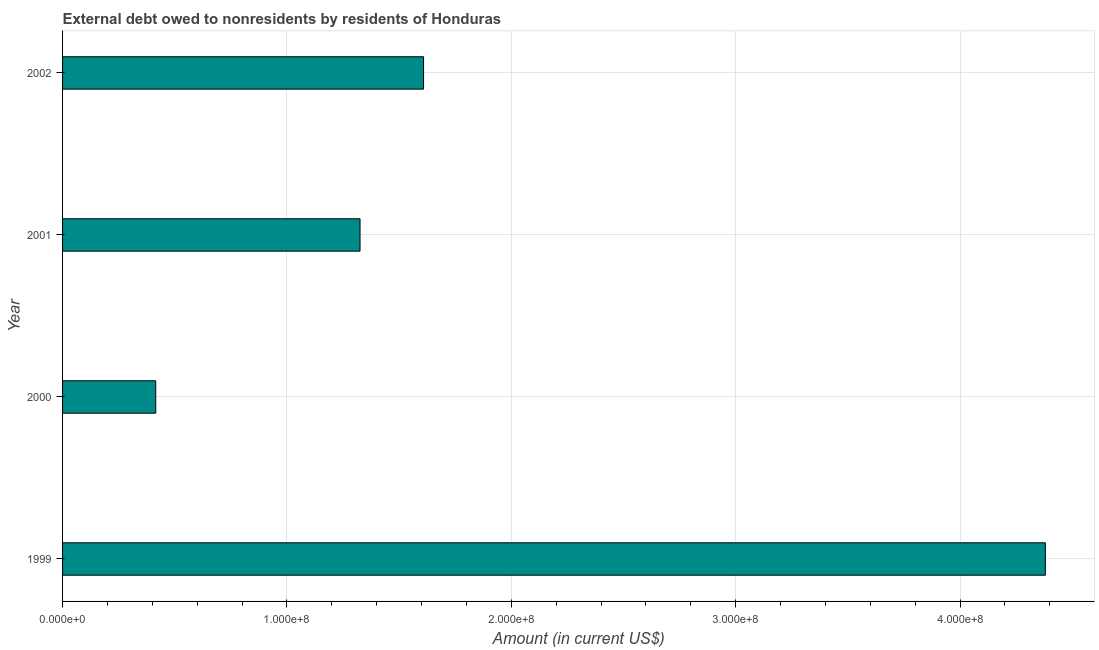Does the graph contain any zero values?
Your response must be concise. No. Does the graph contain grids?
Provide a short and direct response. Yes. What is the title of the graph?
Ensure brevity in your answer.  External debt owed to nonresidents by residents of Honduras. What is the label or title of the X-axis?
Make the answer very short. Amount (in current US$). What is the debt in 2001?
Ensure brevity in your answer.  1.33e+08. Across all years, what is the maximum debt?
Provide a succinct answer. 4.38e+08. Across all years, what is the minimum debt?
Your response must be concise. 4.15e+07. What is the sum of the debt?
Ensure brevity in your answer.  7.73e+08. What is the difference between the debt in 2001 and 2002?
Your answer should be compact. -2.83e+07. What is the average debt per year?
Your response must be concise. 1.93e+08. What is the median debt?
Offer a very short reply. 1.47e+08. In how many years, is the debt greater than 420000000 US$?
Offer a terse response. 1. What is the ratio of the debt in 1999 to that in 2002?
Give a very brief answer. 2.72. Is the debt in 1999 less than that in 2002?
Give a very brief answer. No. What is the difference between the highest and the second highest debt?
Your answer should be very brief. 2.77e+08. Is the sum of the debt in 1999 and 2002 greater than the maximum debt across all years?
Keep it short and to the point. Yes. What is the difference between the highest and the lowest debt?
Offer a very short reply. 3.97e+08. How many bars are there?
Provide a short and direct response. 4. Are all the bars in the graph horizontal?
Make the answer very short. Yes. What is the difference between two consecutive major ticks on the X-axis?
Provide a succinct answer. 1.00e+08. What is the Amount (in current US$) in 1999?
Your answer should be compact. 4.38e+08. What is the Amount (in current US$) of 2000?
Offer a terse response. 4.15e+07. What is the Amount (in current US$) of 2001?
Give a very brief answer. 1.33e+08. What is the Amount (in current US$) of 2002?
Provide a succinct answer. 1.61e+08. What is the difference between the Amount (in current US$) in 1999 and 2000?
Your answer should be very brief. 3.97e+08. What is the difference between the Amount (in current US$) in 1999 and 2001?
Offer a terse response. 3.05e+08. What is the difference between the Amount (in current US$) in 1999 and 2002?
Your answer should be very brief. 2.77e+08. What is the difference between the Amount (in current US$) in 2000 and 2001?
Make the answer very short. -9.11e+07. What is the difference between the Amount (in current US$) in 2000 and 2002?
Your answer should be compact. -1.19e+08. What is the difference between the Amount (in current US$) in 2001 and 2002?
Offer a very short reply. -2.83e+07. What is the ratio of the Amount (in current US$) in 1999 to that in 2000?
Offer a terse response. 10.55. What is the ratio of the Amount (in current US$) in 1999 to that in 2001?
Keep it short and to the point. 3.3. What is the ratio of the Amount (in current US$) in 1999 to that in 2002?
Give a very brief answer. 2.72. What is the ratio of the Amount (in current US$) in 2000 to that in 2001?
Your answer should be very brief. 0.31. What is the ratio of the Amount (in current US$) in 2000 to that in 2002?
Provide a succinct answer. 0.26. What is the ratio of the Amount (in current US$) in 2001 to that in 2002?
Offer a terse response. 0.82. 